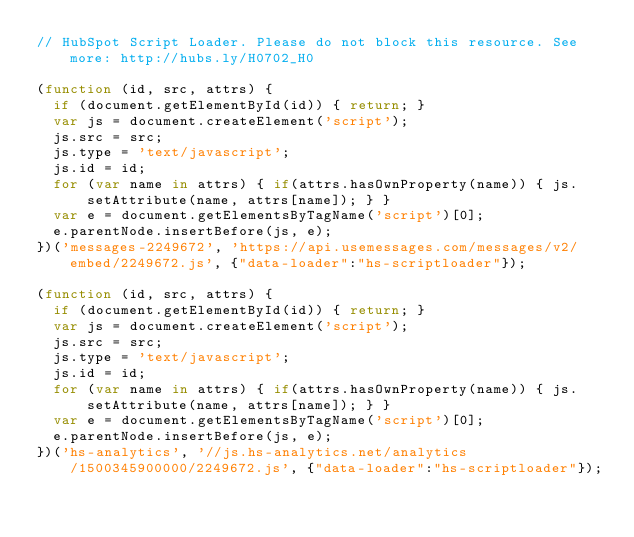Convert code to text. <code><loc_0><loc_0><loc_500><loc_500><_JavaScript_>// HubSpot Script Loader. Please do not block this resource. See more: http://hubs.ly/H0702_H0

(function (id, src, attrs) {
  if (document.getElementById(id)) { return; }
  var js = document.createElement('script');
  js.src = src;
  js.type = 'text/javascript';
  js.id = id;
  for (var name in attrs) { if(attrs.hasOwnProperty(name)) { js.setAttribute(name, attrs[name]); } }
  var e = document.getElementsByTagName('script')[0];
  e.parentNode.insertBefore(js, e);
})('messages-2249672', 'https://api.usemessages.com/messages/v2/embed/2249672.js', {"data-loader":"hs-scriptloader"});

(function (id, src, attrs) {
  if (document.getElementById(id)) { return; }
  var js = document.createElement('script');
  js.src = src;
  js.type = 'text/javascript';
  js.id = id;
  for (var name in attrs) { if(attrs.hasOwnProperty(name)) { js.setAttribute(name, attrs[name]); } }
  var e = document.getElementsByTagName('script')[0];
  e.parentNode.insertBefore(js, e);
})('hs-analytics', '//js.hs-analytics.net/analytics/1500345900000/2249672.js', {"data-loader":"hs-scriptloader"});
</code> 